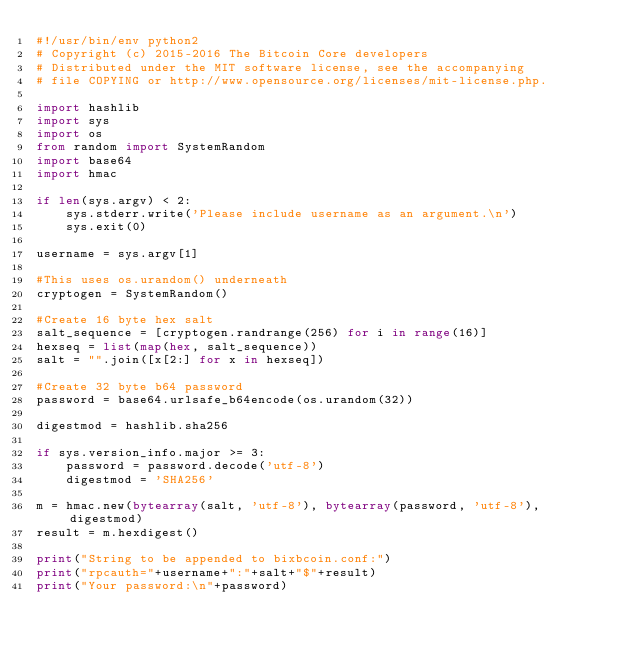Convert code to text. <code><loc_0><loc_0><loc_500><loc_500><_Python_>#!/usr/bin/env python2 
# Copyright (c) 2015-2016 The Bitcoin Core developers
# Distributed under the MIT software license, see the accompanying 
# file COPYING or http://www.opensource.org/licenses/mit-license.php.

import hashlib
import sys
import os
from random import SystemRandom
import base64
import hmac

if len(sys.argv) < 2:
    sys.stderr.write('Please include username as an argument.\n')
    sys.exit(0)

username = sys.argv[1]

#This uses os.urandom() underneath
cryptogen = SystemRandom()

#Create 16 byte hex salt
salt_sequence = [cryptogen.randrange(256) for i in range(16)]
hexseq = list(map(hex, salt_sequence))
salt = "".join([x[2:] for x in hexseq])

#Create 32 byte b64 password
password = base64.urlsafe_b64encode(os.urandom(32))

digestmod = hashlib.sha256

if sys.version_info.major >= 3:
    password = password.decode('utf-8')
    digestmod = 'SHA256'
 
m = hmac.new(bytearray(salt, 'utf-8'), bytearray(password, 'utf-8'), digestmod)
result = m.hexdigest()

print("String to be appended to bixbcoin.conf:")
print("rpcauth="+username+":"+salt+"$"+result)
print("Your password:\n"+password)
</code> 